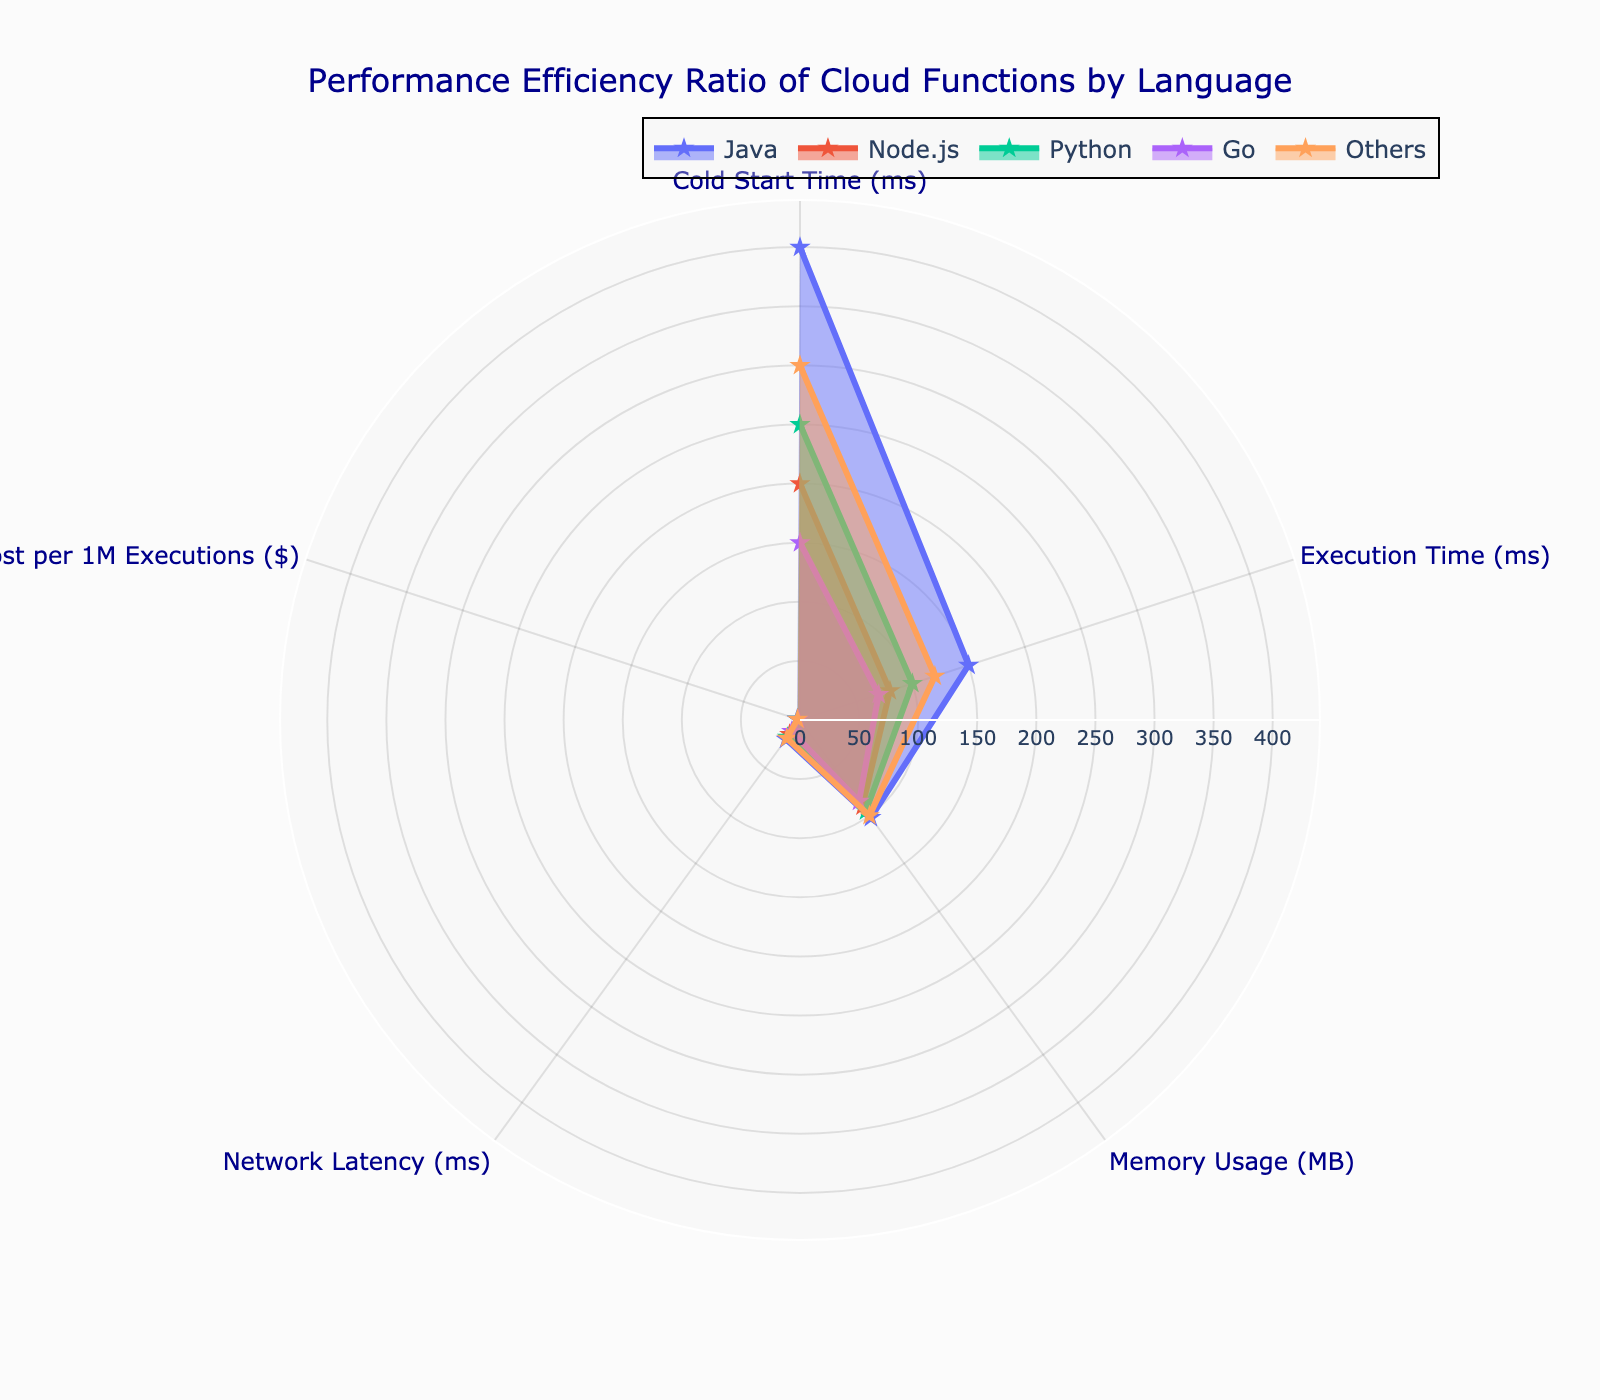Which language has the highest cold start time? By observing the plot, the highest cold start time is represented by the longest radius for the "Cold Start Time (ms)" category. Java has the highest cold start time.
Answer: Java What is the range of the memory usage across the languages? The memory usage across languages ranges from the minimum value to the maximum value in the 'Memory Usage (MB)' category. The minimum is 85MB for Go, and the maximum is 102MB for Java. Thus, the range is 102 - 85.
Answer: 17MB Which language has the lowest network latency? By observing the plot, the shortest radius for the "Network Latency (ms)" category represents the lowest network latency. Go has the lowest network latency.
Answer: Go What is the average execution time of all languages? The execution times for all languages are 150ms (Java), 80ms (Node.js), 100ms (Python), 70ms (Go), and 120ms (Others). To find the average, sum these values and divide by the number of languages: (150 + 80 + 100 + 70 + 120) / 5 = 104ms.
Answer: 104ms Which language has the highest cost per 1M executions? How much higher is it compared to Go? Java has the highest cost per 1M executions ($2.50). The cost of Go is $1.50. The difference is $2.50 - $1.50.
Answer: $1.00 How does the cold start time of Python compare to Node.js? Python has a cold start time of 250ms, while Node.js has a cold start time of 200ms. Python's cold start time is higher than Node.js by 50ms.
Answer: 50ms higher Which language has the overall best performance considering all the metrics? The language with the best performance would typically have lower values across all metrics. Go shows lower values in network latency, execution time, and cost per 1M executions, indicating better performance.
Answer: Go What's the general trend you observe in the correlation between execution time and cost per 1M executions? Observing execution time and cost per 1M executions, languages with shorter execution times like Go and Node.js tend to have lower costs, implying a positive correlation.
Answer: Shorter execution times correlate with lower costs Between Java and Others, which language uses more memory, and what is the difference? Java uses 102MB and Others use 100MB. The difference in memory usage is 102 - 100.
Answer: 2MB Comparing Node.js and Python, which one has a shorter execution time and by how much? Node.js has an execution time of 80ms, while Python has 100ms. Node.js has a shorter execution time by 100 - 80.
Answer: 20ms 